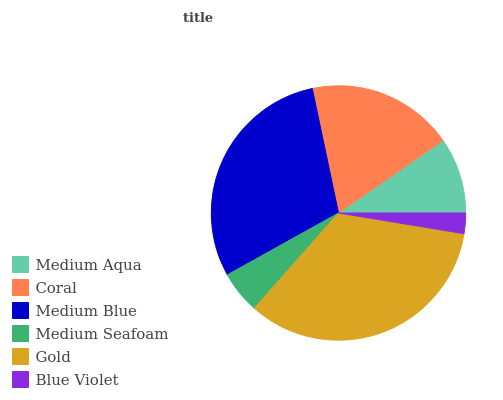Is Blue Violet the minimum?
Answer yes or no. Yes. Is Gold the maximum?
Answer yes or no. Yes. Is Coral the minimum?
Answer yes or no. No. Is Coral the maximum?
Answer yes or no. No. Is Coral greater than Medium Aqua?
Answer yes or no. Yes. Is Medium Aqua less than Coral?
Answer yes or no. Yes. Is Medium Aqua greater than Coral?
Answer yes or no. No. Is Coral less than Medium Aqua?
Answer yes or no. No. Is Coral the high median?
Answer yes or no. Yes. Is Medium Aqua the low median?
Answer yes or no. Yes. Is Gold the high median?
Answer yes or no. No. Is Blue Violet the low median?
Answer yes or no. No. 